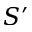<formula> <loc_0><loc_0><loc_500><loc_500>S ^ { \prime }</formula> 